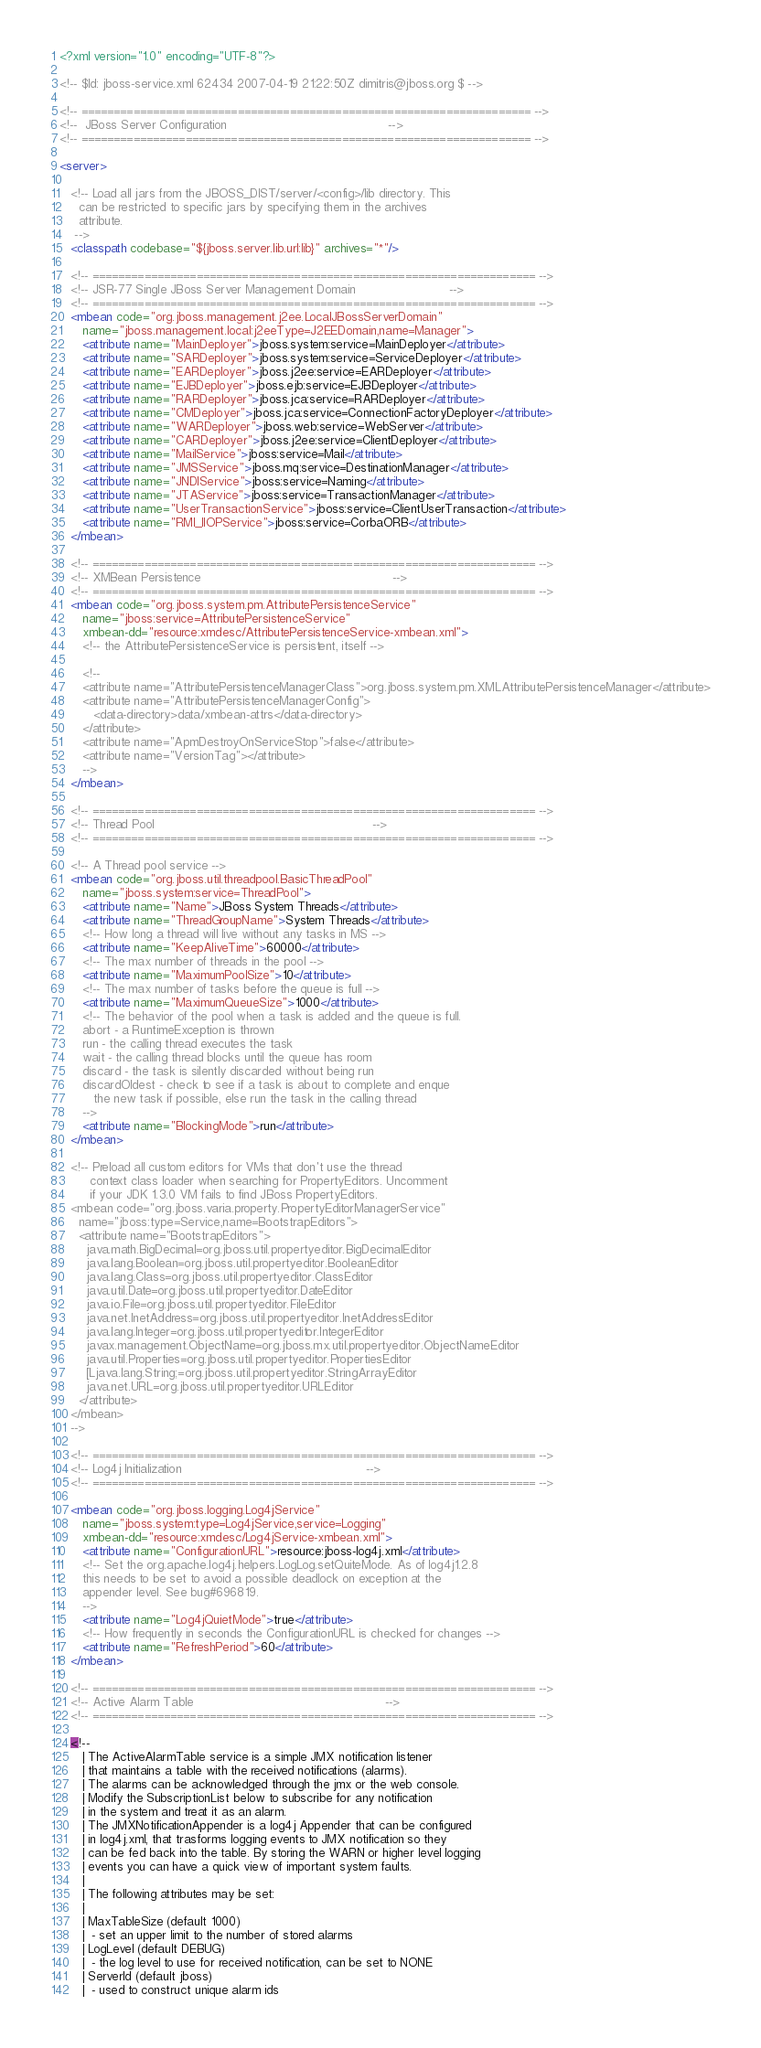<code> <loc_0><loc_0><loc_500><loc_500><_XML_><?xml version="1.0" encoding="UTF-8"?>

<!-- $Id: jboss-service.xml 62434 2007-04-19 21:22:50Z dimitris@jboss.org $ -->

<!-- ===================================================================== -->
<!--  JBoss Server Configuration                                           -->
<!-- ===================================================================== -->

<server>

   <!-- Load all jars from the JBOSS_DIST/server/<config>/lib directory. This
     can be restricted to specific jars by specifying them in the archives
     attribute.
    -->
   <classpath codebase="${jboss.server.lib.url:lib}" archives="*"/>

   <!-- ==================================================================== -->
   <!-- JSR-77 Single JBoss Server Management Domain                         -->
   <!-- ==================================================================== -->
   <mbean code="org.jboss.management.j2ee.LocalJBossServerDomain"
      name="jboss.management.local:j2eeType=J2EEDomain,name=Manager">
      <attribute name="MainDeployer">jboss.system:service=MainDeployer</attribute>
      <attribute name="SARDeployer">jboss.system:service=ServiceDeployer</attribute>
      <attribute name="EARDeployer">jboss.j2ee:service=EARDeployer</attribute>
      <attribute name="EJBDeployer">jboss.ejb:service=EJBDeployer</attribute>
      <attribute name="RARDeployer">jboss.jca:service=RARDeployer</attribute>
      <attribute name="CMDeployer">jboss.jca:service=ConnectionFactoryDeployer</attribute>
      <attribute name="WARDeployer">jboss.web:service=WebServer</attribute>
      <attribute name="CARDeployer">jboss.j2ee:service=ClientDeployer</attribute>
      <attribute name="MailService">jboss:service=Mail</attribute>
      <attribute name="JMSService">jboss.mq:service=DestinationManager</attribute>
      <attribute name="JNDIService">jboss:service=Naming</attribute>
      <attribute name="JTAService">jboss:service=TransactionManager</attribute>
      <attribute name="UserTransactionService">jboss:service=ClientUserTransaction</attribute>
      <attribute name="RMI_IIOPService">jboss:service=CorbaORB</attribute>
   </mbean>

   <!-- ==================================================================== -->
   <!-- XMBean Persistence                                                   -->
   <!-- ==================================================================== -->
   <mbean code="org.jboss.system.pm.AttributePersistenceService"
      name="jboss:service=AttributePersistenceService"
      xmbean-dd="resource:xmdesc/AttributePersistenceService-xmbean.xml">
      <!-- the AttributePersistenceService is persistent, itself -->

      <!--
      <attribute name="AttributePersistenceManagerClass">org.jboss.system.pm.XMLAttributePersistenceManager</attribute>
      <attribute name="AttributePersistenceManagerConfig">
         <data-directory>data/xmbean-attrs</data-directory>
      </attribute>
      <attribute name="ApmDestroyOnServiceStop">false</attribute>
      <attribute name="VersionTag"></attribute>
      -->
   </mbean>

   <!-- ==================================================================== -->
   <!-- Thread Pool                                                          -->
   <!-- ==================================================================== -->
   
   <!-- A Thread pool service -->
   <mbean code="org.jboss.util.threadpool.BasicThreadPool"
      name="jboss.system:service=ThreadPool">
      <attribute name="Name">JBoss System Threads</attribute>
      <attribute name="ThreadGroupName">System Threads</attribute>
      <!-- How long a thread will live without any tasks in MS -->
      <attribute name="KeepAliveTime">60000</attribute>
      <!-- The max number of threads in the pool -->
      <attribute name="MaximumPoolSize">10</attribute>
      <!-- The max number of tasks before the queue is full -->
      <attribute name="MaximumQueueSize">1000</attribute>
      <!-- The behavior of the pool when a task is added and the queue is full.
      abort - a RuntimeException is thrown
      run - the calling thread executes the task
      wait - the calling thread blocks until the queue has room
      discard - the task is silently discarded without being run
      discardOldest - check to see if a task is about to complete and enque
         the new task if possible, else run the task in the calling thread
      -->
      <attribute name="BlockingMode">run</attribute>
   </mbean>

   <!-- Preload all custom editors for VMs that don't use the thread
        context class loader when searching for PropertyEditors. Uncomment
        if your JDK 1.3.0 VM fails to find JBoss PropertyEditors.
   <mbean code="org.jboss.varia.property.PropertyEditorManagerService"
     name="jboss:type=Service,name=BootstrapEditors">
     <attribute name="BootstrapEditors">
       java.math.BigDecimal=org.jboss.util.propertyeditor.BigDecimalEditor
       java.lang.Boolean=org.jboss.util.propertyeditor.BooleanEditor
       java.lang.Class=org.jboss.util.propertyeditor.ClassEditor
       java.util.Date=org.jboss.util.propertyeditor.DateEditor
       java.io.File=org.jboss.util.propertyeditor.FileEditor
       java.net.InetAddress=org.jboss.util.propertyeditor.InetAddressEditor
       java.lang.Integer=org.jboss.util.propertyeditor.IntegerEditor
       javax.management.ObjectName=org.jboss.mx.util.propertyeditor.ObjectNameEditor
       java.util.Properties=org.jboss.util.propertyeditor.PropertiesEditor
       [Ljava.lang.String;=org.jboss.util.propertyeditor.StringArrayEditor
       java.net.URL=org.jboss.util.propertyeditor.URLEditor
     </attribute>
   </mbean>
   -->

   <!-- ==================================================================== -->
   <!-- Log4j Initialization                                                 -->
   <!-- ==================================================================== -->

   <mbean code="org.jboss.logging.Log4jService"
      name="jboss.system:type=Log4jService,service=Logging"
	  xmbean-dd="resource:xmdesc/Log4jService-xmbean.xml">
      <attribute name="ConfigurationURL">resource:jboss-log4j.xml</attribute>
      <!-- Set the org.apache.log4j.helpers.LogLog.setQuiteMode. As of log4j1.2.8
      this needs to be set to avoid a possible deadlock on exception at the
      appender level. See bug#696819.
      -->
      <attribute name="Log4jQuietMode">true</attribute>
      <!-- How frequently in seconds the ConfigurationURL is checked for changes -->
      <attribute name="RefreshPeriod">60</attribute>
   </mbean>

   <!-- ==================================================================== -->
   <!-- Active Alarm Table                                                   -->
   <!-- ==================================================================== -->

   <!--
      | The ActiveAlarmTable service is a simple JMX notification listener
      | that maintains a table with the received notifications (alarms).
      | The alarms can be acknowledged through the jmx or the web console.
      | Modify the SubscriptionList below to subscribe for any notification
      | in the system and treat it as an alarm.
      | The JMXNotificationAppender is a log4j Appender that can be configured
      | in log4j.xml, that trasforms logging events to JMX notification so they
      | can be fed back into the table. By storing the WARN or higher level logging
      | events you can have a quick view of important system faults.
      |
      | The following attributes may be set:
      |
      | MaxTableSize (default 1000)
      |  - set an upper limit to the number of stored alarms
      | LogLevel (default DEBUG)
      |  - the log level to use for received notification, can be set to NONE
      | ServerId (default jboss)
      |  - used to construct unique alarm ids</code> 